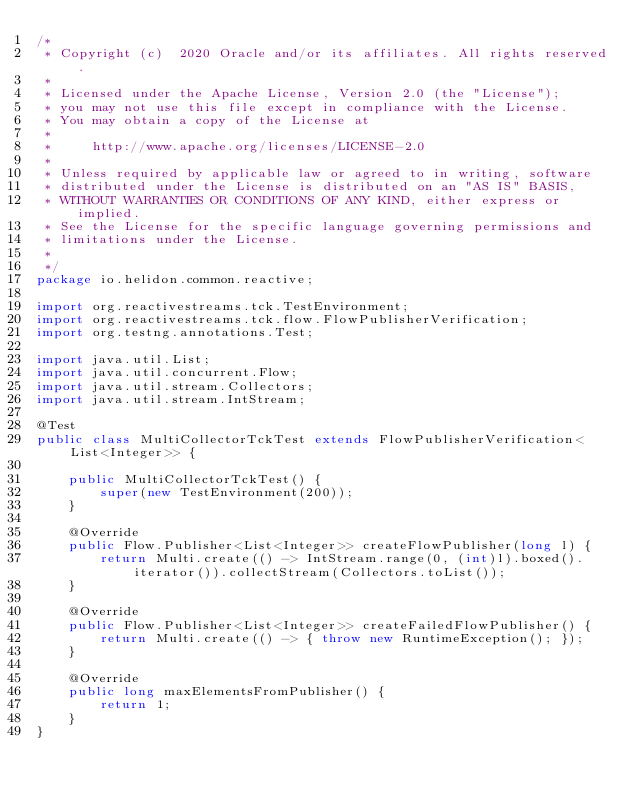<code> <loc_0><loc_0><loc_500><loc_500><_Java_>/*
 * Copyright (c)  2020 Oracle and/or its affiliates. All rights reserved.
 *
 * Licensed under the Apache License, Version 2.0 (the "License");
 * you may not use this file except in compliance with the License.
 * You may obtain a copy of the License at
 *
 *     http://www.apache.org/licenses/LICENSE-2.0
 *
 * Unless required by applicable law or agreed to in writing, software
 * distributed under the License is distributed on an "AS IS" BASIS,
 * WITHOUT WARRANTIES OR CONDITIONS OF ANY KIND, either express or implied.
 * See the License for the specific language governing permissions and
 * limitations under the License.
 *
 */
package io.helidon.common.reactive;

import org.reactivestreams.tck.TestEnvironment;
import org.reactivestreams.tck.flow.FlowPublisherVerification;
import org.testng.annotations.Test;

import java.util.List;
import java.util.concurrent.Flow;
import java.util.stream.Collectors;
import java.util.stream.IntStream;

@Test
public class MultiCollectorTckTest extends FlowPublisherVerification<List<Integer>> {

    public MultiCollectorTckTest() {
        super(new TestEnvironment(200));
    }

    @Override
    public Flow.Publisher<List<Integer>> createFlowPublisher(long l) {
        return Multi.create(() -> IntStream.range(0, (int)l).boxed().iterator()).collectStream(Collectors.toList());
    }

    @Override
    public Flow.Publisher<List<Integer>> createFailedFlowPublisher() {
        return Multi.create(() -> { throw new RuntimeException(); });
    }

    @Override
    public long maxElementsFromPublisher() {
        return 1;
    }
}
</code> 